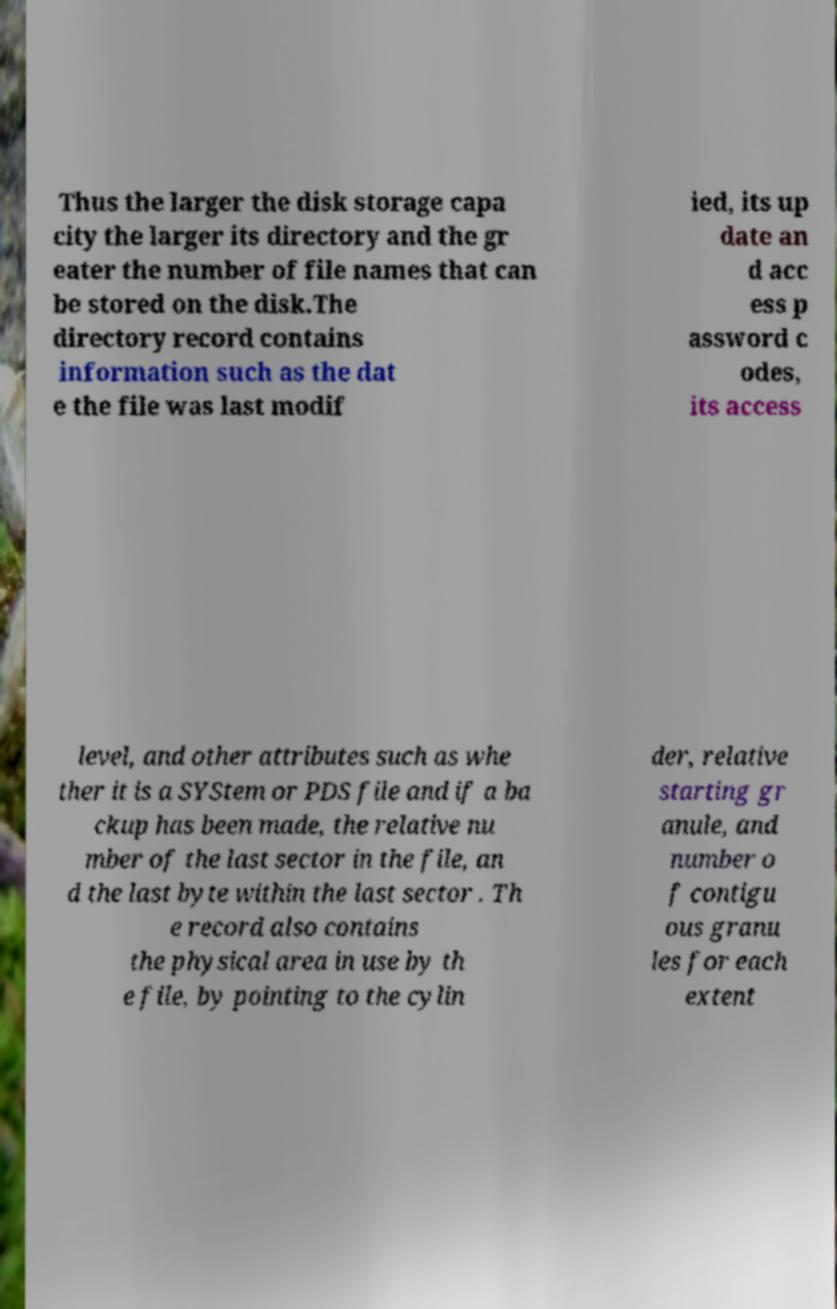Could you extract and type out the text from this image? Thus the larger the disk storage capa city the larger its directory and the gr eater the number of file names that can be stored on the disk.The directory record contains information such as the dat e the file was last modif ied, its up date an d acc ess p assword c odes, its access level, and other attributes such as whe ther it is a SYStem or PDS file and if a ba ckup has been made, the relative nu mber of the last sector in the file, an d the last byte within the last sector . Th e record also contains the physical area in use by th e file, by pointing to the cylin der, relative starting gr anule, and number o f contigu ous granu les for each extent 